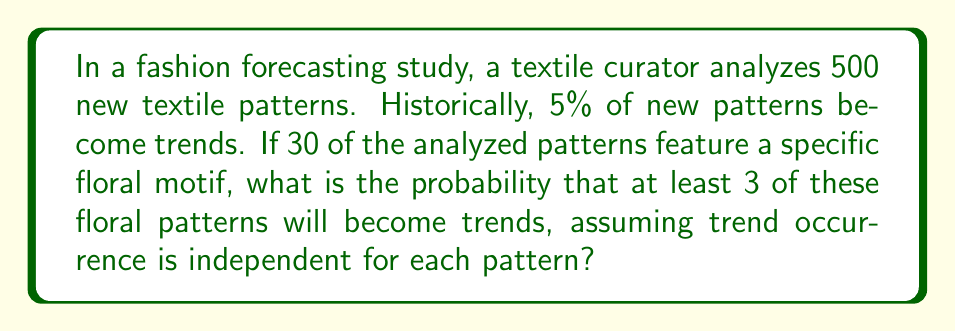Show me your answer to this math problem. Let's approach this step-by-step:

1) We're dealing with a binomial probability problem. We need to find $P(X \geq 3)$, where $X$ is the number of floral patterns that become trends.

2) We know:
   - $n$ (number of trials) = 30 (floral patterns)
   - $p$ (probability of success) = 0.05 (5% chance of becoming a trend)
   - We want $P(X \geq 3)$

3) We can calculate this as: $P(X \geq 3) = 1 - P(X < 3) = 1 - [P(X=0) + P(X=1) + P(X=2)]$

4) The binomial probability formula is:

   $P(X=k) = \binom{n}{k} p^k (1-p)^{n-k}$

5) Let's calculate each probability:

   $P(X=0) = \binom{30}{0} (0.05)^0 (0.95)^{30} = 0.2146$
   
   $P(X=1) = \binom{30}{1} (0.05)^1 (0.95)^{29} = 0.3391$
   
   $P(X=2) = \binom{30}{2} (0.05)^2 (0.95)^{28} = 0.2597$

6) Now we can calculate:

   $P(X \geq 3) = 1 - [P(X=0) + P(X=1) + P(X=2)]$
                $= 1 - [0.2146 + 0.3391 + 0.2597]$
                $= 1 - 0.8134$
                $= 0.1866$

Therefore, the probability that at least 3 of the floral patterns will become trends is approximately 0.1866 or 18.66%.
Answer: 0.1866 